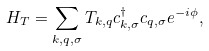Convert formula to latex. <formula><loc_0><loc_0><loc_500><loc_500>H _ { T } = \sum _ { k , q , \sigma } T _ { k , q } c ^ { \dagger } _ { k , \sigma } c _ { q , \sigma } e ^ { - i \phi } ,</formula> 